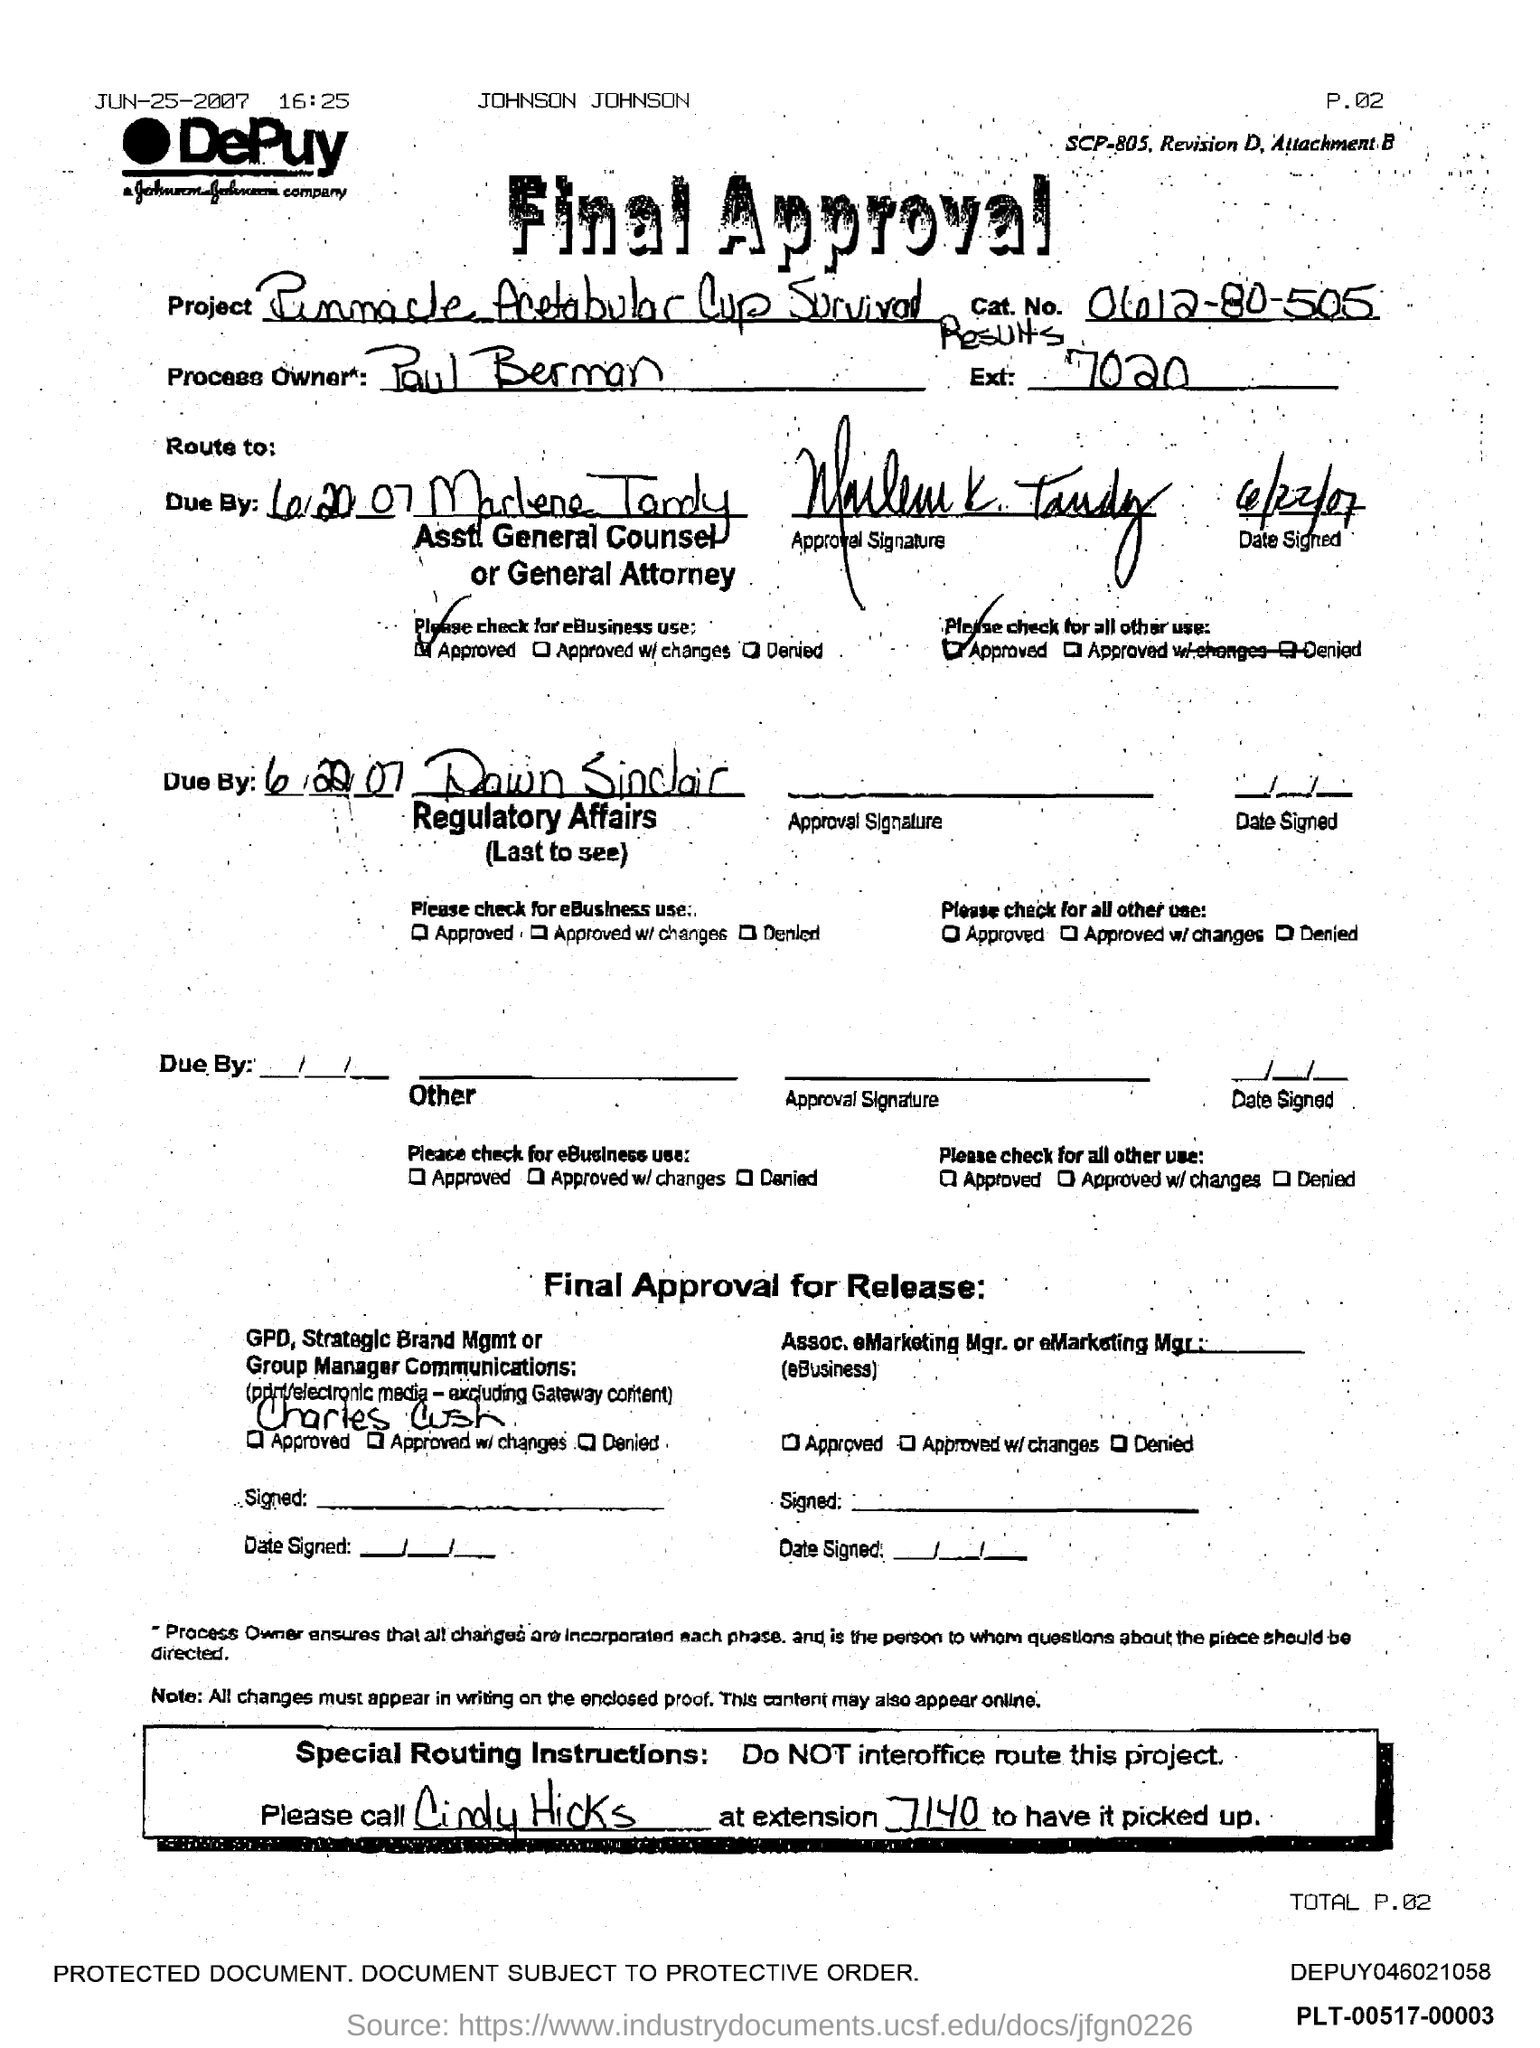What is the cat.no?
Ensure brevity in your answer.  0612-80-505. Who is the Process Owner?
Offer a terse response. Paul Berman. 